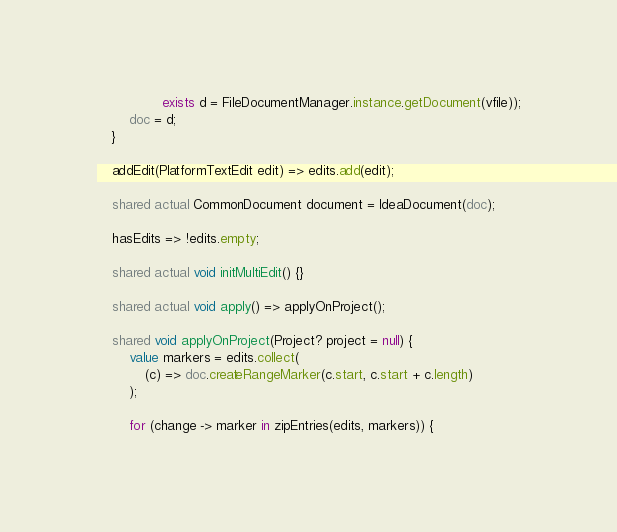<code> <loc_0><loc_0><loc_500><loc_500><_Ceylon_>                exists d = FileDocumentManager.instance.getDocument(vfile));
        doc = d;
    }

    addEdit(PlatformTextEdit edit) => edits.add(edit);

    shared actual CommonDocument document = IdeaDocument(doc);

    hasEdits => !edits.empty;

    shared actual void initMultiEdit() {}

    shared actual void apply() => applyOnProject();

    shared void applyOnProject(Project? project = null) {
        value markers = edits.collect(
            (c) => doc.createRangeMarker(c.start, c.start + c.length)
        );

        for (change -> marker in zipEntries(edits, markers)) {</code> 